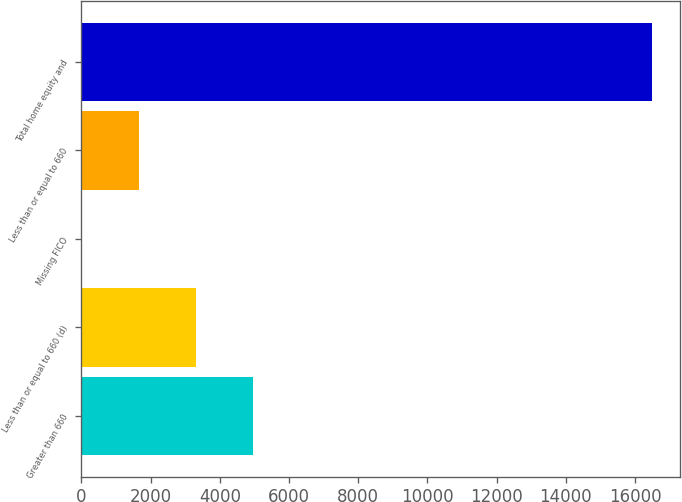Convert chart. <chart><loc_0><loc_0><loc_500><loc_500><bar_chart><fcel>Greater than 660<fcel>Less than or equal to 660 (d)<fcel>Missing FICO<fcel>Less than or equal to 660<fcel>Total home equity and<nl><fcel>4952.3<fcel>3305.2<fcel>11<fcel>1658.1<fcel>16482<nl></chart> 